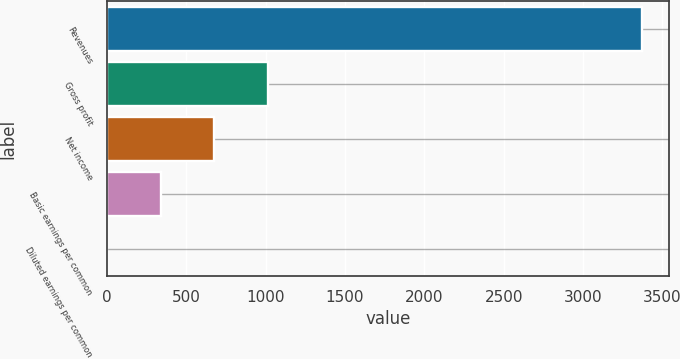Convert chart. <chart><loc_0><loc_0><loc_500><loc_500><bar_chart><fcel>Revenues<fcel>Gross profit<fcel>Net income<fcel>Basic earnings per common<fcel>Diluted earnings per common<nl><fcel>3370.2<fcel>1011.87<fcel>674.97<fcel>338.07<fcel>1.17<nl></chart> 